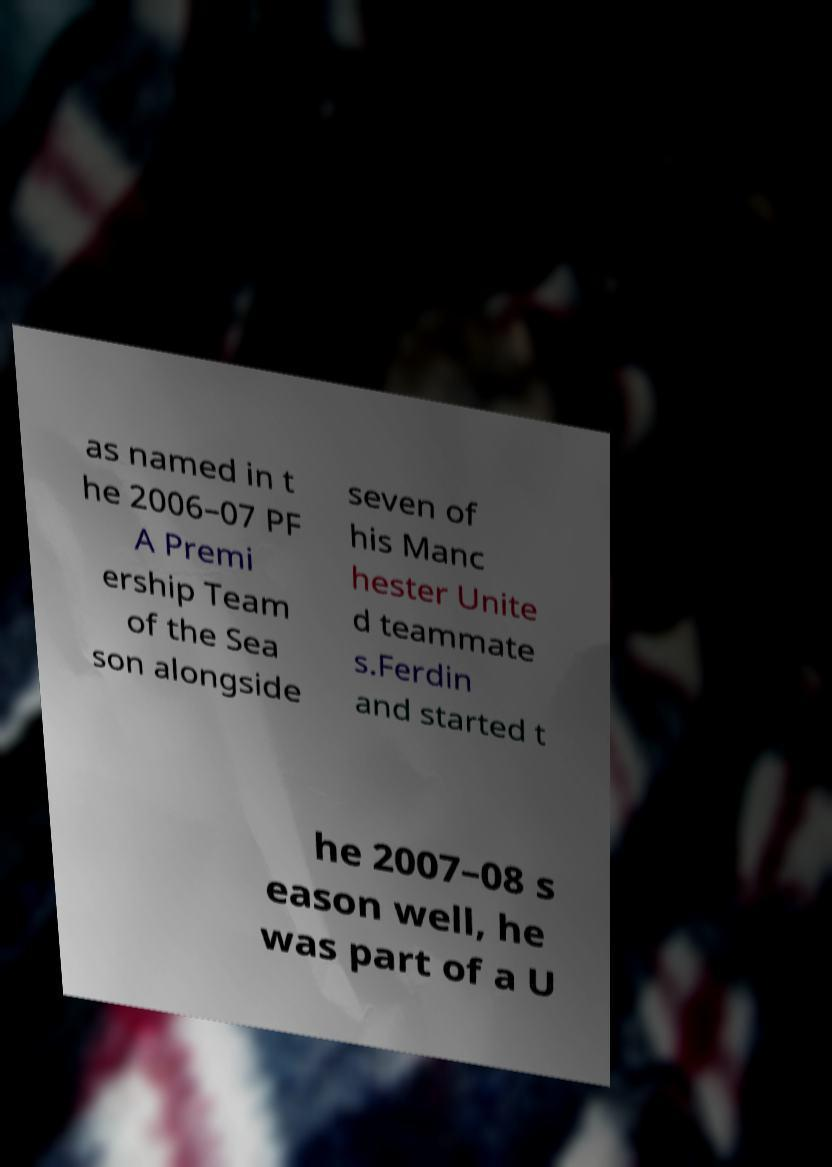Please read and relay the text visible in this image. What does it say? as named in t he 2006–07 PF A Premi ership Team of the Sea son alongside seven of his Manc hester Unite d teammate s.Ferdin and started t he 2007–08 s eason well, he was part of a U 